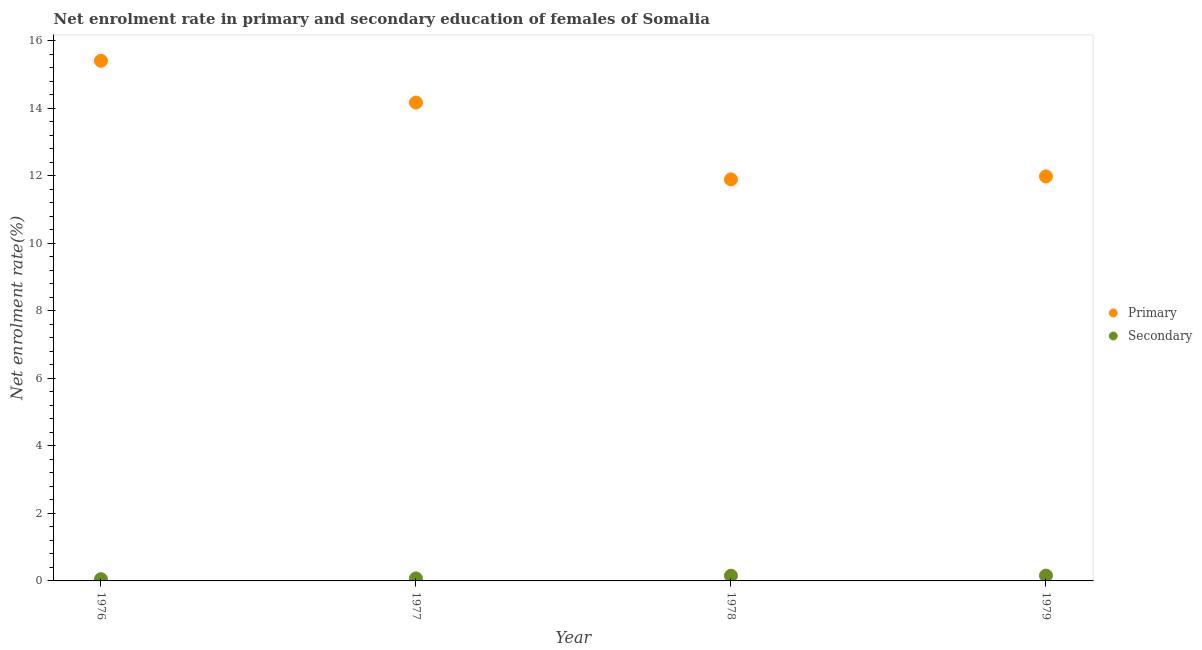Is the number of dotlines equal to the number of legend labels?
Keep it short and to the point. Yes. What is the enrollment rate in secondary education in 1977?
Your response must be concise. 0.07. Across all years, what is the maximum enrollment rate in secondary education?
Your answer should be compact. 0.16. Across all years, what is the minimum enrollment rate in secondary education?
Ensure brevity in your answer.  0.05. In which year was the enrollment rate in primary education maximum?
Make the answer very short. 1976. In which year was the enrollment rate in primary education minimum?
Give a very brief answer. 1978. What is the total enrollment rate in secondary education in the graph?
Make the answer very short. 0.44. What is the difference between the enrollment rate in primary education in 1977 and that in 1979?
Offer a very short reply. 2.19. What is the difference between the enrollment rate in secondary education in 1979 and the enrollment rate in primary education in 1976?
Give a very brief answer. -15.24. What is the average enrollment rate in primary education per year?
Offer a terse response. 13.36. In the year 1976, what is the difference between the enrollment rate in secondary education and enrollment rate in primary education?
Ensure brevity in your answer.  -15.35. In how many years, is the enrollment rate in primary education greater than 15.2 %?
Offer a terse response. 1. What is the ratio of the enrollment rate in secondary education in 1978 to that in 1979?
Keep it short and to the point. 0.98. Is the difference between the enrollment rate in primary education in 1977 and 1979 greater than the difference between the enrollment rate in secondary education in 1977 and 1979?
Your response must be concise. Yes. What is the difference between the highest and the second highest enrollment rate in primary education?
Your answer should be compact. 1.24. What is the difference between the highest and the lowest enrollment rate in secondary education?
Your answer should be compact. 0.11. Is the sum of the enrollment rate in primary education in 1978 and 1979 greater than the maximum enrollment rate in secondary education across all years?
Make the answer very short. Yes. Does the enrollment rate in secondary education monotonically increase over the years?
Offer a very short reply. Yes. Is the enrollment rate in primary education strictly greater than the enrollment rate in secondary education over the years?
Provide a short and direct response. Yes. Is the enrollment rate in primary education strictly less than the enrollment rate in secondary education over the years?
Give a very brief answer. No. How many dotlines are there?
Provide a short and direct response. 2. Does the graph contain any zero values?
Your answer should be compact. No. Does the graph contain grids?
Offer a very short reply. No. How many legend labels are there?
Make the answer very short. 2. What is the title of the graph?
Offer a very short reply. Net enrolment rate in primary and secondary education of females of Somalia. Does "Depositors" appear as one of the legend labels in the graph?
Your answer should be compact. No. What is the label or title of the X-axis?
Your answer should be compact. Year. What is the label or title of the Y-axis?
Offer a very short reply. Net enrolment rate(%). What is the Net enrolment rate(%) in Primary in 1976?
Offer a terse response. 15.4. What is the Net enrolment rate(%) of Secondary in 1976?
Your answer should be compact. 0.05. What is the Net enrolment rate(%) of Primary in 1977?
Your answer should be very brief. 14.17. What is the Net enrolment rate(%) of Secondary in 1977?
Your answer should be compact. 0.07. What is the Net enrolment rate(%) of Primary in 1978?
Offer a very short reply. 11.89. What is the Net enrolment rate(%) of Secondary in 1978?
Give a very brief answer. 0.15. What is the Net enrolment rate(%) of Primary in 1979?
Offer a terse response. 11.98. What is the Net enrolment rate(%) of Secondary in 1979?
Make the answer very short. 0.16. Across all years, what is the maximum Net enrolment rate(%) of Primary?
Offer a terse response. 15.4. Across all years, what is the maximum Net enrolment rate(%) of Secondary?
Provide a short and direct response. 0.16. Across all years, what is the minimum Net enrolment rate(%) of Primary?
Offer a very short reply. 11.89. Across all years, what is the minimum Net enrolment rate(%) of Secondary?
Offer a terse response. 0.05. What is the total Net enrolment rate(%) in Primary in the graph?
Give a very brief answer. 53.44. What is the total Net enrolment rate(%) in Secondary in the graph?
Offer a terse response. 0.44. What is the difference between the Net enrolment rate(%) of Primary in 1976 and that in 1977?
Provide a short and direct response. 1.24. What is the difference between the Net enrolment rate(%) of Secondary in 1976 and that in 1977?
Your answer should be compact. -0.02. What is the difference between the Net enrolment rate(%) of Primary in 1976 and that in 1978?
Offer a terse response. 3.51. What is the difference between the Net enrolment rate(%) in Secondary in 1976 and that in 1978?
Make the answer very short. -0.1. What is the difference between the Net enrolment rate(%) of Primary in 1976 and that in 1979?
Make the answer very short. 3.42. What is the difference between the Net enrolment rate(%) of Secondary in 1976 and that in 1979?
Make the answer very short. -0.11. What is the difference between the Net enrolment rate(%) of Primary in 1977 and that in 1978?
Offer a very short reply. 2.28. What is the difference between the Net enrolment rate(%) of Secondary in 1977 and that in 1978?
Your answer should be very brief. -0.08. What is the difference between the Net enrolment rate(%) in Primary in 1977 and that in 1979?
Your answer should be very brief. 2.19. What is the difference between the Net enrolment rate(%) of Secondary in 1977 and that in 1979?
Your response must be concise. -0.08. What is the difference between the Net enrolment rate(%) in Primary in 1978 and that in 1979?
Provide a short and direct response. -0.09. What is the difference between the Net enrolment rate(%) of Secondary in 1978 and that in 1979?
Your response must be concise. -0. What is the difference between the Net enrolment rate(%) in Primary in 1976 and the Net enrolment rate(%) in Secondary in 1977?
Your response must be concise. 15.33. What is the difference between the Net enrolment rate(%) of Primary in 1976 and the Net enrolment rate(%) of Secondary in 1978?
Your answer should be very brief. 15.25. What is the difference between the Net enrolment rate(%) of Primary in 1976 and the Net enrolment rate(%) of Secondary in 1979?
Provide a succinct answer. 15.24. What is the difference between the Net enrolment rate(%) of Primary in 1977 and the Net enrolment rate(%) of Secondary in 1978?
Offer a very short reply. 14.01. What is the difference between the Net enrolment rate(%) in Primary in 1977 and the Net enrolment rate(%) in Secondary in 1979?
Provide a succinct answer. 14.01. What is the difference between the Net enrolment rate(%) in Primary in 1978 and the Net enrolment rate(%) in Secondary in 1979?
Provide a short and direct response. 11.73. What is the average Net enrolment rate(%) of Primary per year?
Your answer should be compact. 13.36. What is the average Net enrolment rate(%) of Secondary per year?
Provide a short and direct response. 0.11. In the year 1976, what is the difference between the Net enrolment rate(%) in Primary and Net enrolment rate(%) in Secondary?
Make the answer very short. 15.35. In the year 1977, what is the difference between the Net enrolment rate(%) of Primary and Net enrolment rate(%) of Secondary?
Your answer should be very brief. 14.09. In the year 1978, what is the difference between the Net enrolment rate(%) of Primary and Net enrolment rate(%) of Secondary?
Your answer should be very brief. 11.74. In the year 1979, what is the difference between the Net enrolment rate(%) in Primary and Net enrolment rate(%) in Secondary?
Keep it short and to the point. 11.82. What is the ratio of the Net enrolment rate(%) of Primary in 1976 to that in 1977?
Ensure brevity in your answer.  1.09. What is the ratio of the Net enrolment rate(%) in Secondary in 1976 to that in 1977?
Make the answer very short. 0.69. What is the ratio of the Net enrolment rate(%) of Primary in 1976 to that in 1978?
Your response must be concise. 1.3. What is the ratio of the Net enrolment rate(%) of Secondary in 1976 to that in 1978?
Make the answer very short. 0.33. What is the ratio of the Net enrolment rate(%) of Primary in 1976 to that in 1979?
Make the answer very short. 1.29. What is the ratio of the Net enrolment rate(%) of Secondary in 1976 to that in 1979?
Ensure brevity in your answer.  0.33. What is the ratio of the Net enrolment rate(%) of Primary in 1977 to that in 1978?
Give a very brief answer. 1.19. What is the ratio of the Net enrolment rate(%) in Secondary in 1977 to that in 1978?
Offer a very short reply. 0.48. What is the ratio of the Net enrolment rate(%) in Primary in 1977 to that in 1979?
Offer a very short reply. 1.18. What is the ratio of the Net enrolment rate(%) in Secondary in 1977 to that in 1979?
Make the answer very short. 0.47. What is the ratio of the Net enrolment rate(%) in Primary in 1978 to that in 1979?
Your answer should be very brief. 0.99. What is the ratio of the Net enrolment rate(%) in Secondary in 1978 to that in 1979?
Make the answer very short. 0.98. What is the difference between the highest and the second highest Net enrolment rate(%) in Primary?
Your response must be concise. 1.24. What is the difference between the highest and the second highest Net enrolment rate(%) of Secondary?
Offer a very short reply. 0. What is the difference between the highest and the lowest Net enrolment rate(%) in Primary?
Offer a very short reply. 3.51. What is the difference between the highest and the lowest Net enrolment rate(%) of Secondary?
Your answer should be very brief. 0.11. 